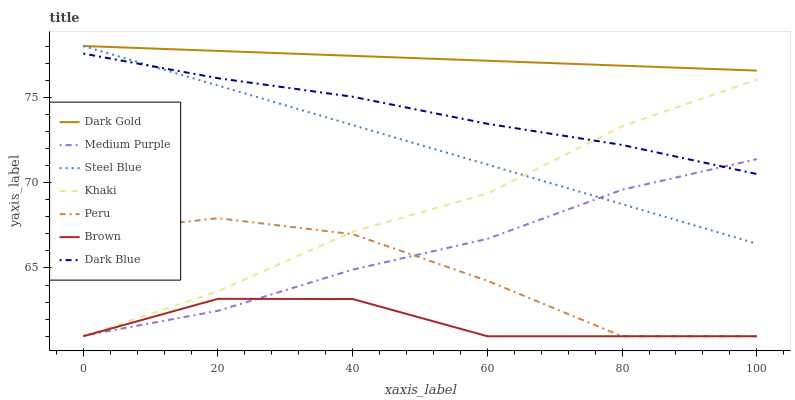Does Brown have the minimum area under the curve?
Answer yes or no. Yes. Does Khaki have the minimum area under the curve?
Answer yes or no. No. Does Khaki have the maximum area under the curve?
Answer yes or no. No. Is Steel Blue the smoothest?
Answer yes or no. Yes. Is Peru the roughest?
Answer yes or no. Yes. Is Khaki the smoothest?
Answer yes or no. No. Is Khaki the roughest?
Answer yes or no. No. Does Dark Gold have the lowest value?
Answer yes or no. No. Does Khaki have the highest value?
Answer yes or no. No. Is Brown less than Dark Gold?
Answer yes or no. Yes. Is Dark Blue greater than Peru?
Answer yes or no. Yes. Does Brown intersect Dark Gold?
Answer yes or no. No. 